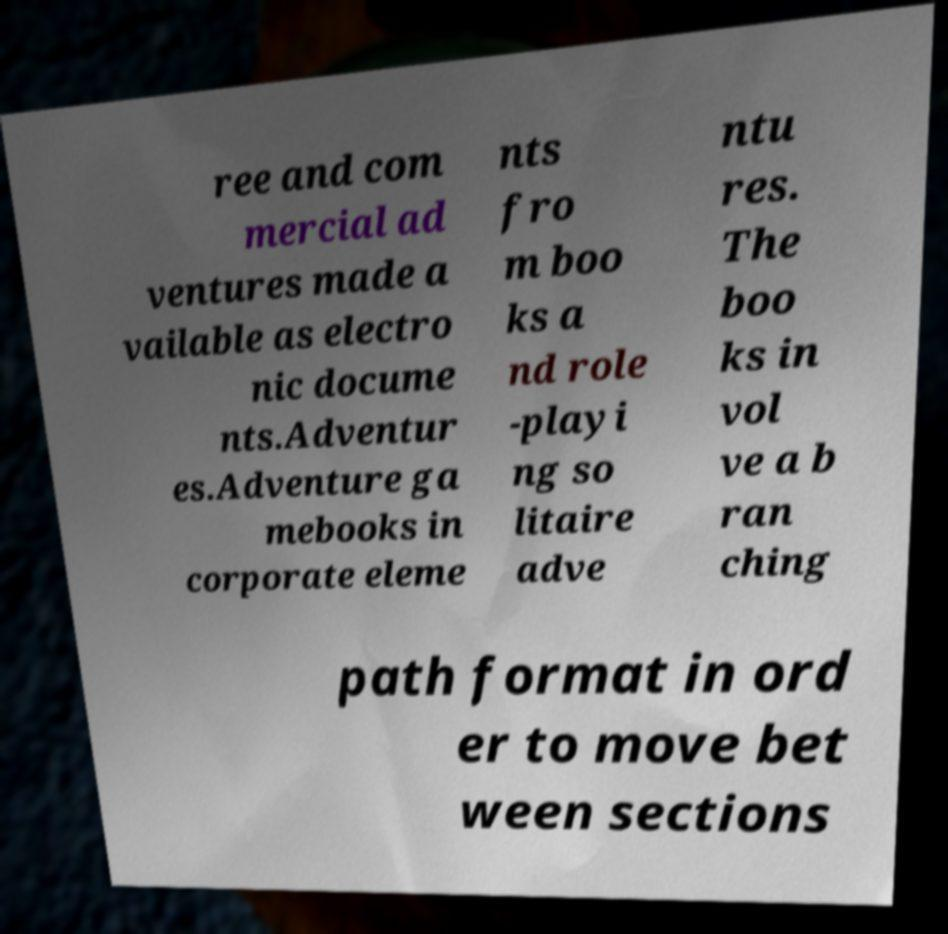Could you assist in decoding the text presented in this image and type it out clearly? ree and com mercial ad ventures made a vailable as electro nic docume nts.Adventur es.Adventure ga mebooks in corporate eleme nts fro m boo ks a nd role -playi ng so litaire adve ntu res. The boo ks in vol ve a b ran ching path format in ord er to move bet ween sections 